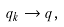<formula> <loc_0><loc_0><loc_500><loc_500>q _ { k } \to q ,</formula> 